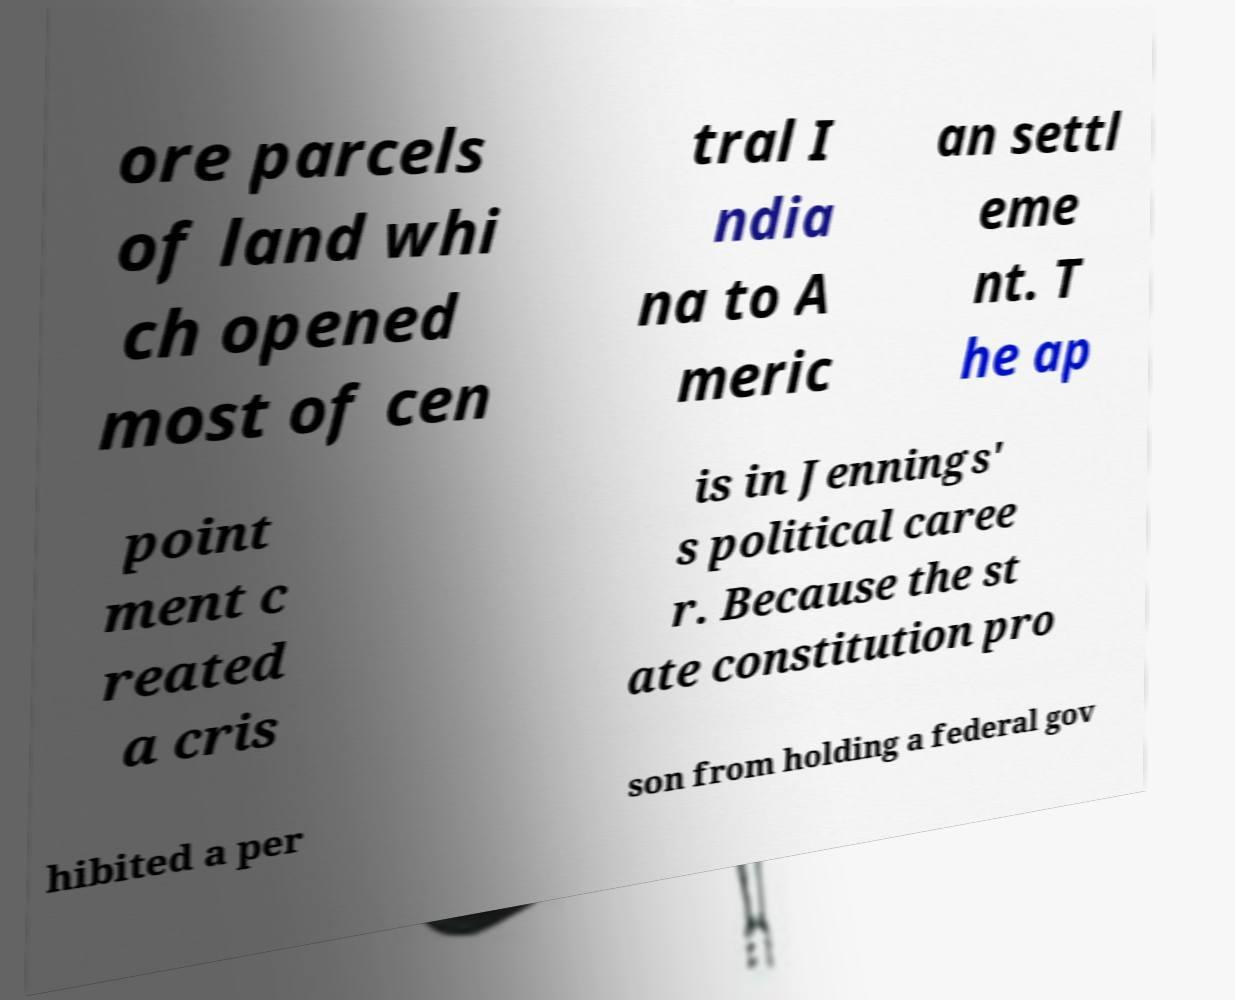I need the written content from this picture converted into text. Can you do that? ore parcels of land whi ch opened most of cen tral I ndia na to A meric an settl eme nt. T he ap point ment c reated a cris is in Jennings' s political caree r. Because the st ate constitution pro hibited a per son from holding a federal gov 